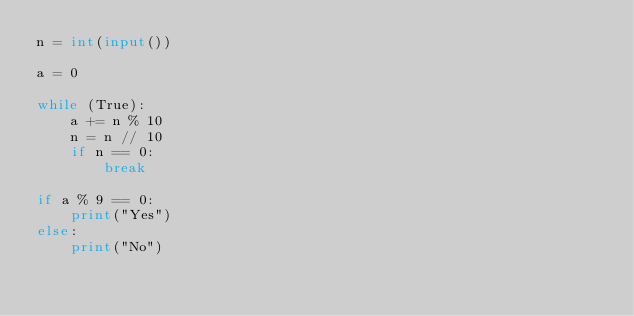<code> <loc_0><loc_0><loc_500><loc_500><_Python_>n = int(input())

a = 0

while (True):
    a += n % 10
    n = n // 10
    if n == 0:
        break

if a % 9 == 0:
    print("Yes")
else:
    print("No")
</code> 